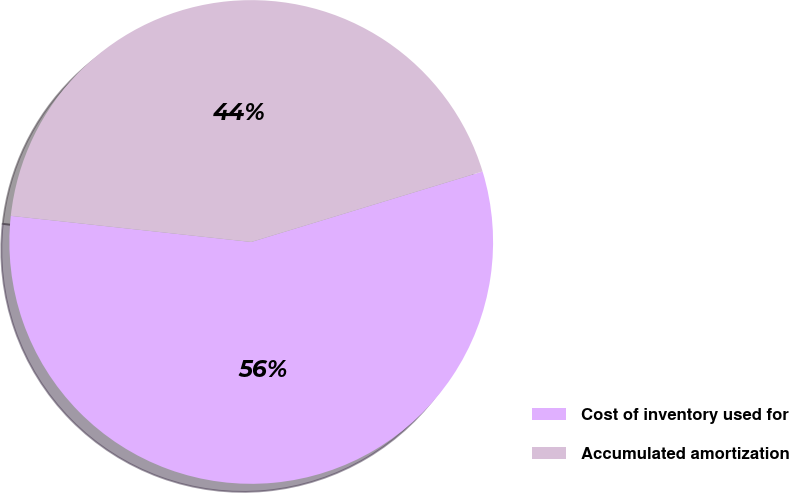<chart> <loc_0><loc_0><loc_500><loc_500><pie_chart><fcel>Cost of inventory used for<fcel>Accumulated amortization<nl><fcel>56.43%<fcel>43.57%<nl></chart> 